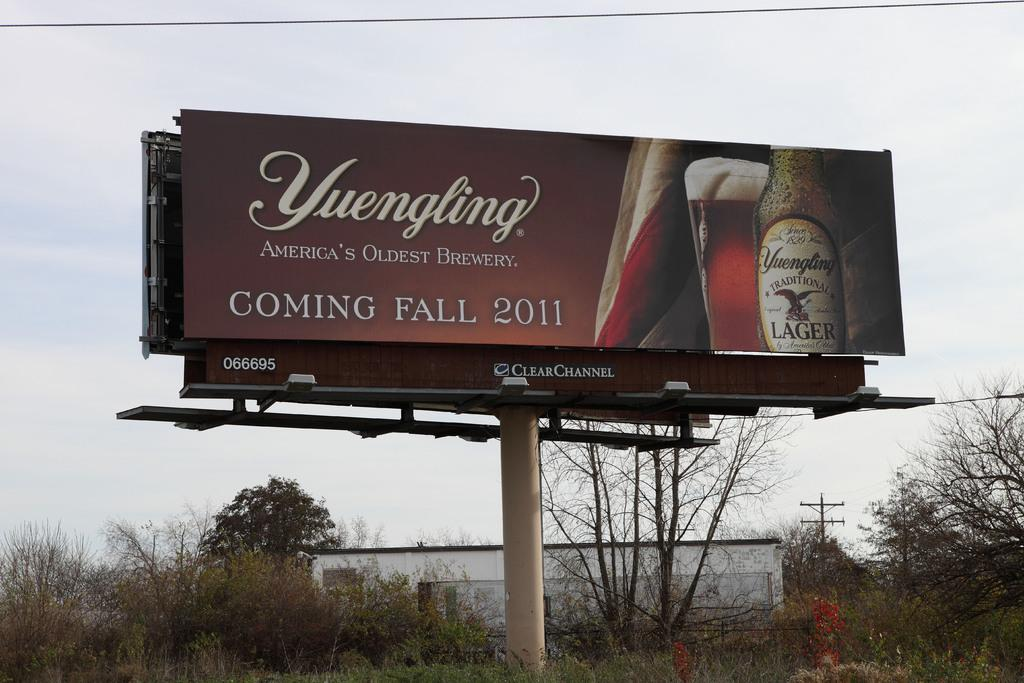<image>
Give a short and clear explanation of the subsequent image. A large billboard says Yuengling America's Oldest Brewery and shows a beer bottle and mug. 